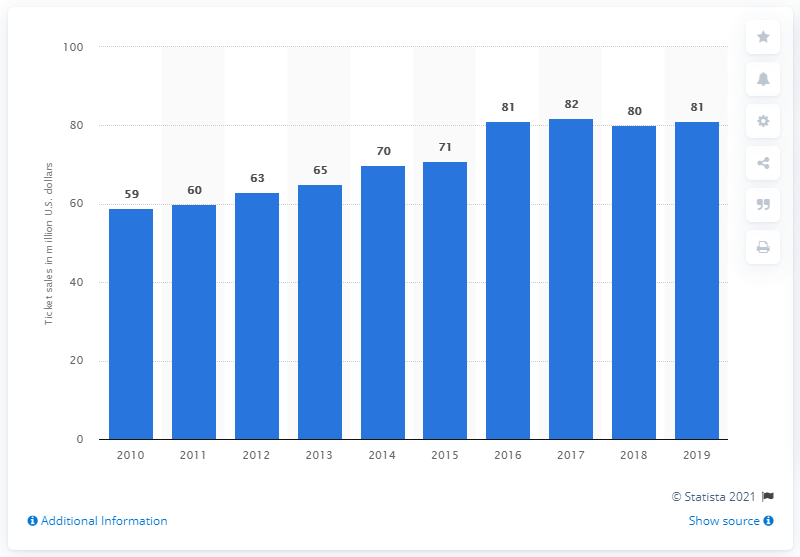Give some essential details in this illustration. The Denver Broncos generated approximately $81 million in revenue from gate receipts in 2019. 